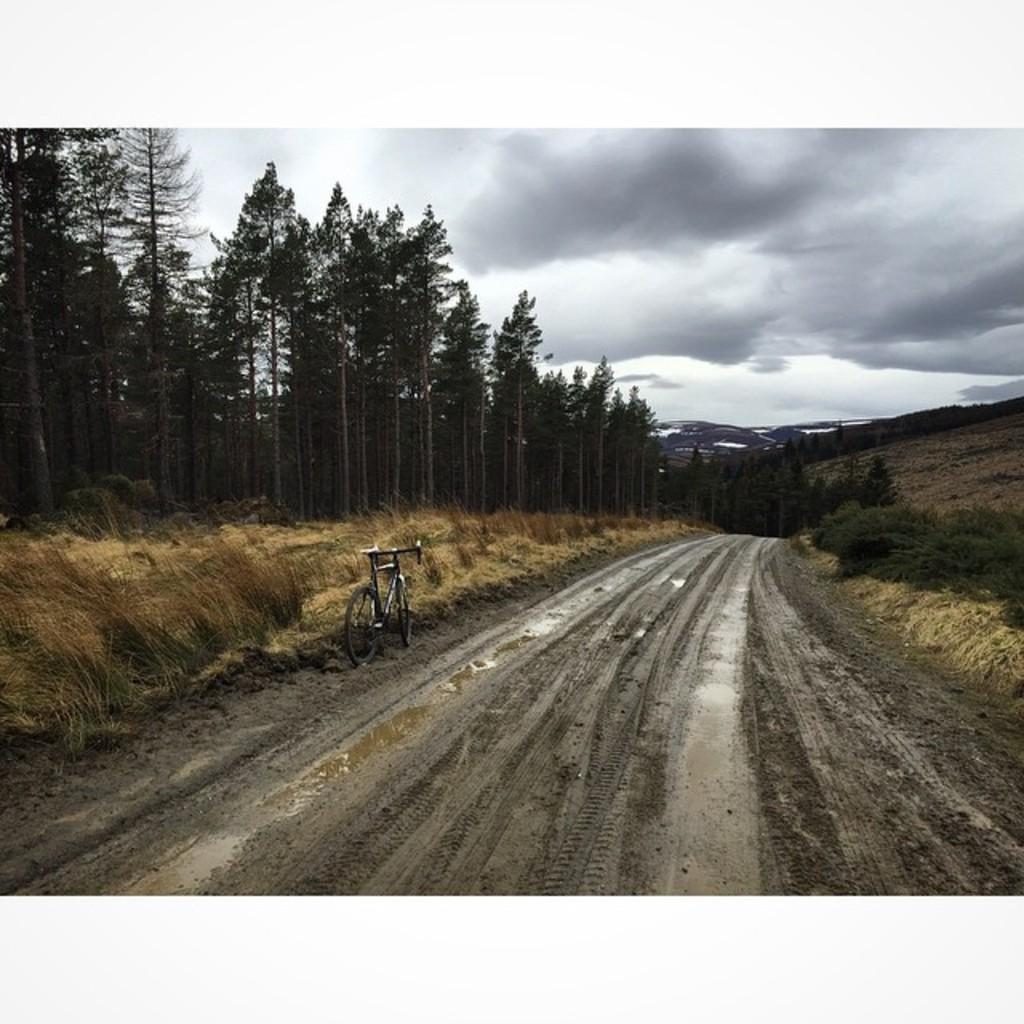What is the main feature in the center of the image? There is a mud road in the center of the image. What mode of transportation can be seen in the image? There is a bicycle in the image. What type of vegetation is on the left side of the image? There are trees at the left side of the image. What is visible in the sky in the image? There are clouds visible at the top of the image. What is the name of the visitor in the image? There is no visitor present in the image, so it is not possible to determine their name. 